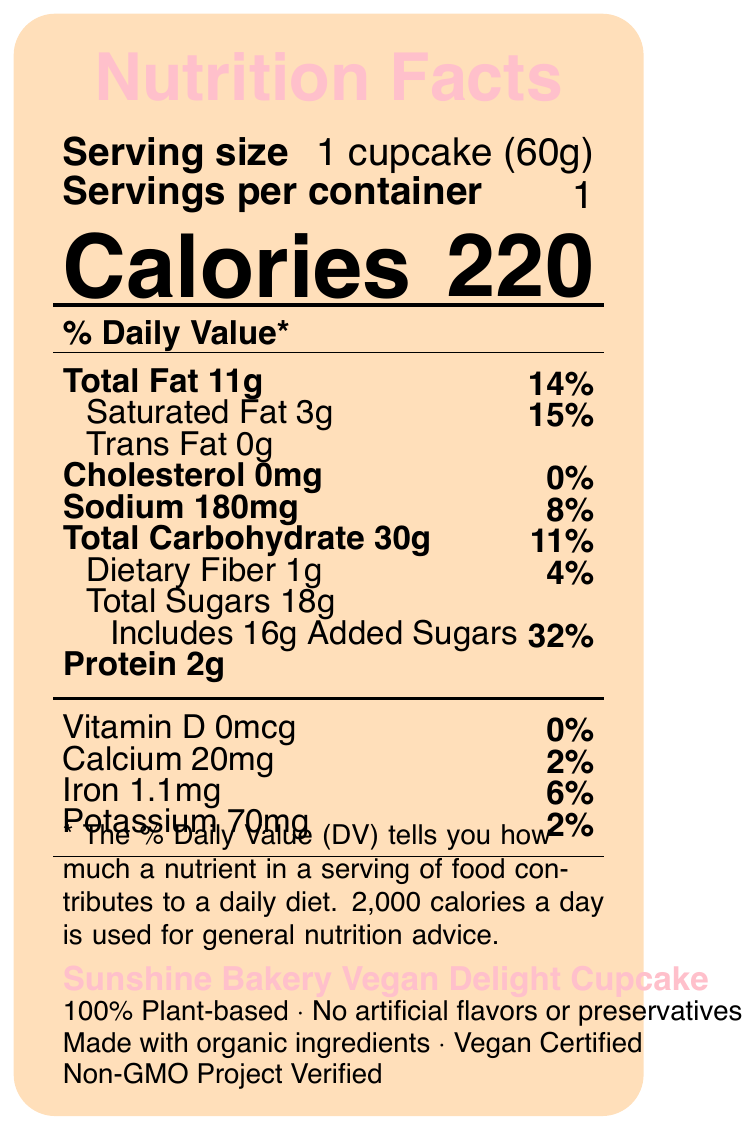What is the serving size of the Vegan Delight Cupcake? The serving size is specified as "1 cupcake (60g)" on the document.
Answer: 1 cupcake (60g) How many calories are there per serving of the Vegan Delight Cupcake? The document states there are 220 calories per serving.
Answer: 220 What percentage of the daily value for total fat is in one serving of the Vegan Delight Cupcake? The document indicates that the cupcake contains 11g of total fat which amounts to 14% of the daily value.
Answer: 14% How much protein does each Vegan Delight Cupcake contain? The document shows that each cupcake has 2g of protein.
Answer: 2g What are the main plant-based ingredients in the Vegan Delight Cupcake? These ingredients are listed under the "ingredients" section of the document.
Answer: Organic wheat flour, organic cane sugar, coconut oil, almond milk, applesauce, baking powder, vanilla extract, sea salt Is the Vegan Delight Cupcake cholesterol-free? The document states that the cupcake contains 0mg of cholesterol.
Answer: Yes Which of the following is NOT an allergen listed for the Vegan Delight Cupcake? A. Wheat B. Almonds C. Soy D. Dairy The document lists wheat and tree nuts (almonds) as allergens. It also mentions the facility processes soy but does not list dairy as an allergen.
Answer: D What certifications does the Vegan Delight Cupcake have? A. Gluten-Free Certified B. Non-GMO Project Verified C. USDA Organic Certified D. Vegan Certified The certifications for the product include "Vegan Certified" and "Non-GMO Project Verified," per the document.
Answer: B and D Does the Vegan Delight Cupcake contain any added sugars? The document notes that the cupcake includes 16g of added sugars.
Answer: Yes Can you determine the exact fiber content of the Vegan Delight Cupcake from the document? The document states that the dietary fiber content is 1g.
Answer: Yes Summarize the main nutritional aspects and certifications of the Vegan Delight Cupcake. This description covers the major points related to nutrition, ingredients, and certifications as presented in the document.
Answer: The Sunshine Bakery Vegan Delight Cupcake is a 100% plant-based product made with organic ingredients and certified as Vegan and Non-GMO Project Verified. It provides 220 calories per serving, with 11g of total fat, 3g of saturated fat, and no cholesterol. The cupcake contains 30g of carbohydrates including 18g of total sugars with 16g added sugars, 2g of protein, and various vitamins and minerals with low percentages of the daily values. How much sodium is in the Vegan Delight Cupcake? The sodium content is listed as 180mg in the document.
Answer: 180mg What percentage of the daily value for iron is in one serving of the Vegan Delight Cupcake? The document indicates that the iron content is 1.1mg, which is 6% of the daily value.
Answer: 6% What is the amount of saturated fat in the Vegan Delight Cupcake? The document specifies that the saturated fat content is 3g.
Answer: 3g Which company produces the Vegan Delight Cupcake? The document lists "Sunshine Bakery" as the producer.
Answer: Sunshine Bakery What is the full address of Sunshine Bakery? The address is listed as "123 Main Street, Anytown, USA 12345" in the bakery information section.
Answer: 123 Main Street, Anytown, USA 12345 What is the contact phone number for Sunshine Bakery? The phone number provided in the document is (555) 123-4567.
Answer: (555) 123-4567 What marketing claims does the Sunshine Bakery make about the Vegan Delight Cupcake? The document includes these marketing claims under the "marketingClaims" section.
Answer: 100% Plant-based, No artificial flavors or preservatives, Made with organic ingredients Does the nutrition label provide information about the environmental impact of the cupcake's packaging? The document features a sustainability note indicating the packaging is made from 100% recycled materials and encourages recycling.
Answer: Yes Is the Vegan Delight Cupcake suitable for people with tree nut allergies? The document lists almonds (a tree nut) as an ingredient and allergen, so it is not suitable for people with tree nut allergies.
Answer: No How many total sugars are in one serving of the Vegan Delight Cupcake? The document specifies that there are 18g of total sugars in one serving.
Answer: 18g How many calories are in a container of the Vegan Delight Cupcake? With 1 serving per container and each serving being 220 calories, the total is 220 calories per container.
Answer: 220 Does the Vegan Delight Cupcake contain any trans fat? The document states that the cupcake contains 0g of trans fat.
Answer: No 